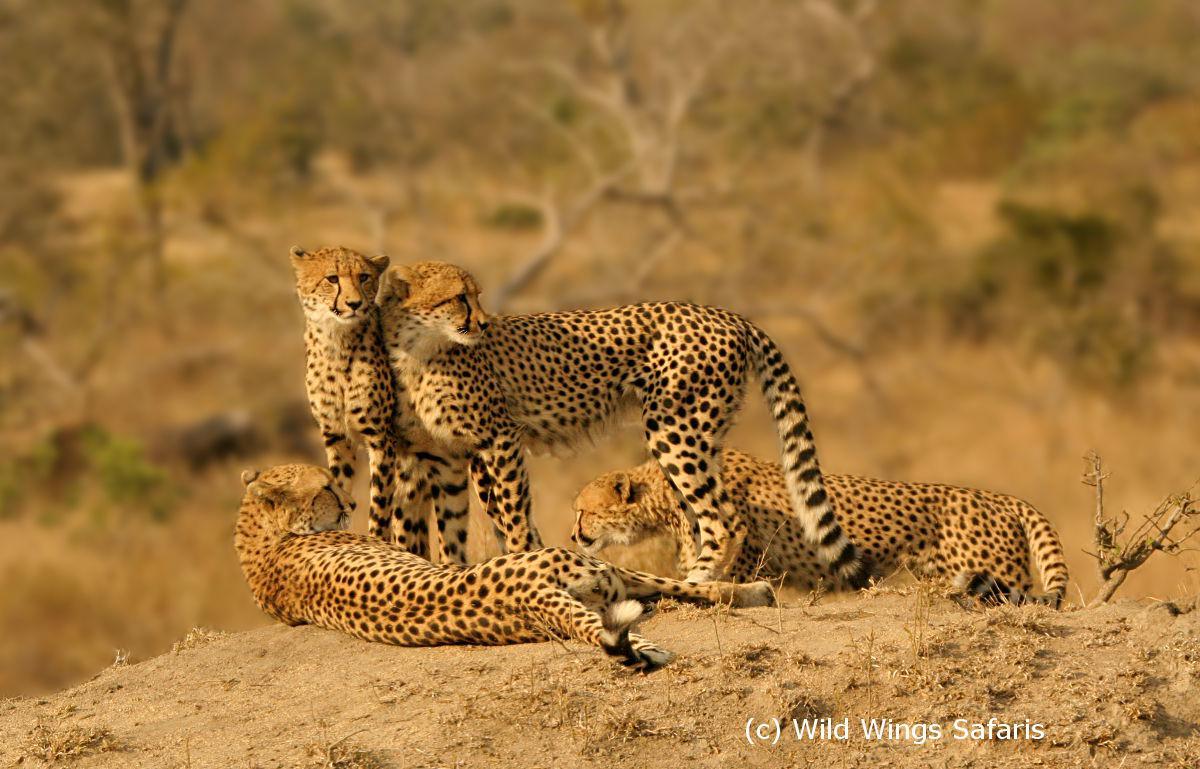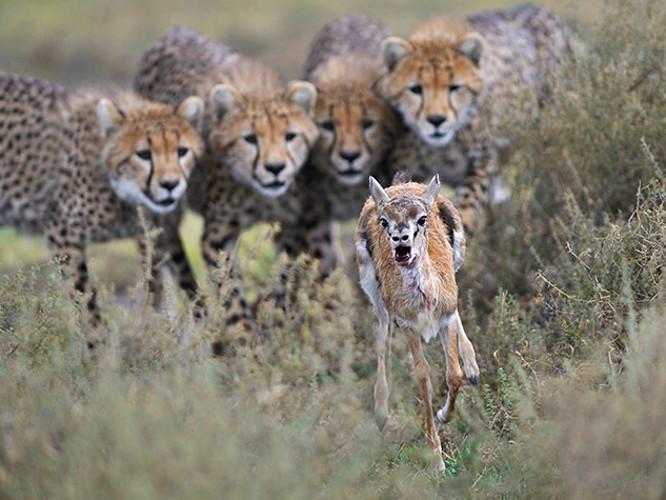The first image is the image on the left, the second image is the image on the right. Evaluate the accuracy of this statement regarding the images: "The cheetahs are shown with their prey in at least one of the images.". Is it true? Answer yes or no. Yes. The first image is the image on the left, the second image is the image on the right. For the images shown, is this caption "Each image shows a close group of wild cats, and no image shows a prey animal." true? Answer yes or no. No. 